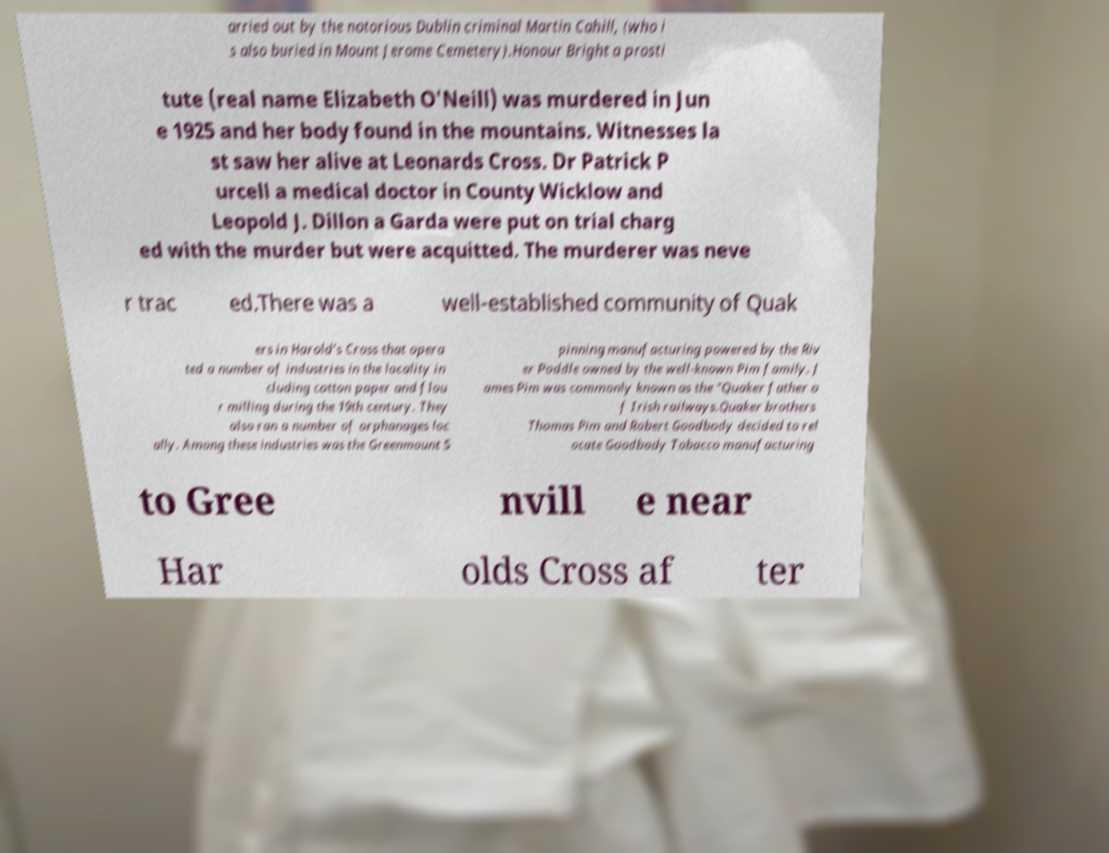Please read and relay the text visible in this image. What does it say? arried out by the notorious Dublin criminal Martin Cahill, (who i s also buried in Mount Jerome Cemetery).Honour Bright a prosti tute (real name Elizabeth O'Neill) was murdered in Jun e 1925 and her body found in the mountains. Witnesses la st saw her alive at Leonards Cross. Dr Patrick P urcell a medical doctor in County Wicklow and Leopold J. Dillon a Garda were put on trial charg ed with the murder but were acquitted. The murderer was neve r trac ed.There was a well-established community of Quak ers in Harold's Cross that opera ted a number of industries in the locality in cluding cotton paper and flou r milling during the 19th century. They also ran a number of orphanages loc ally. Among these industries was the Greenmount S pinning manufacturing powered by the Riv er Poddle owned by the well-known Pim family. J ames Pim was commonly known as the "Quaker father o f Irish railways.Quaker brothers Thomas Pim and Robert Goodbody decided to rel ocate Goodbody Tobacco manufacturing to Gree nvill e near Har olds Cross af ter 